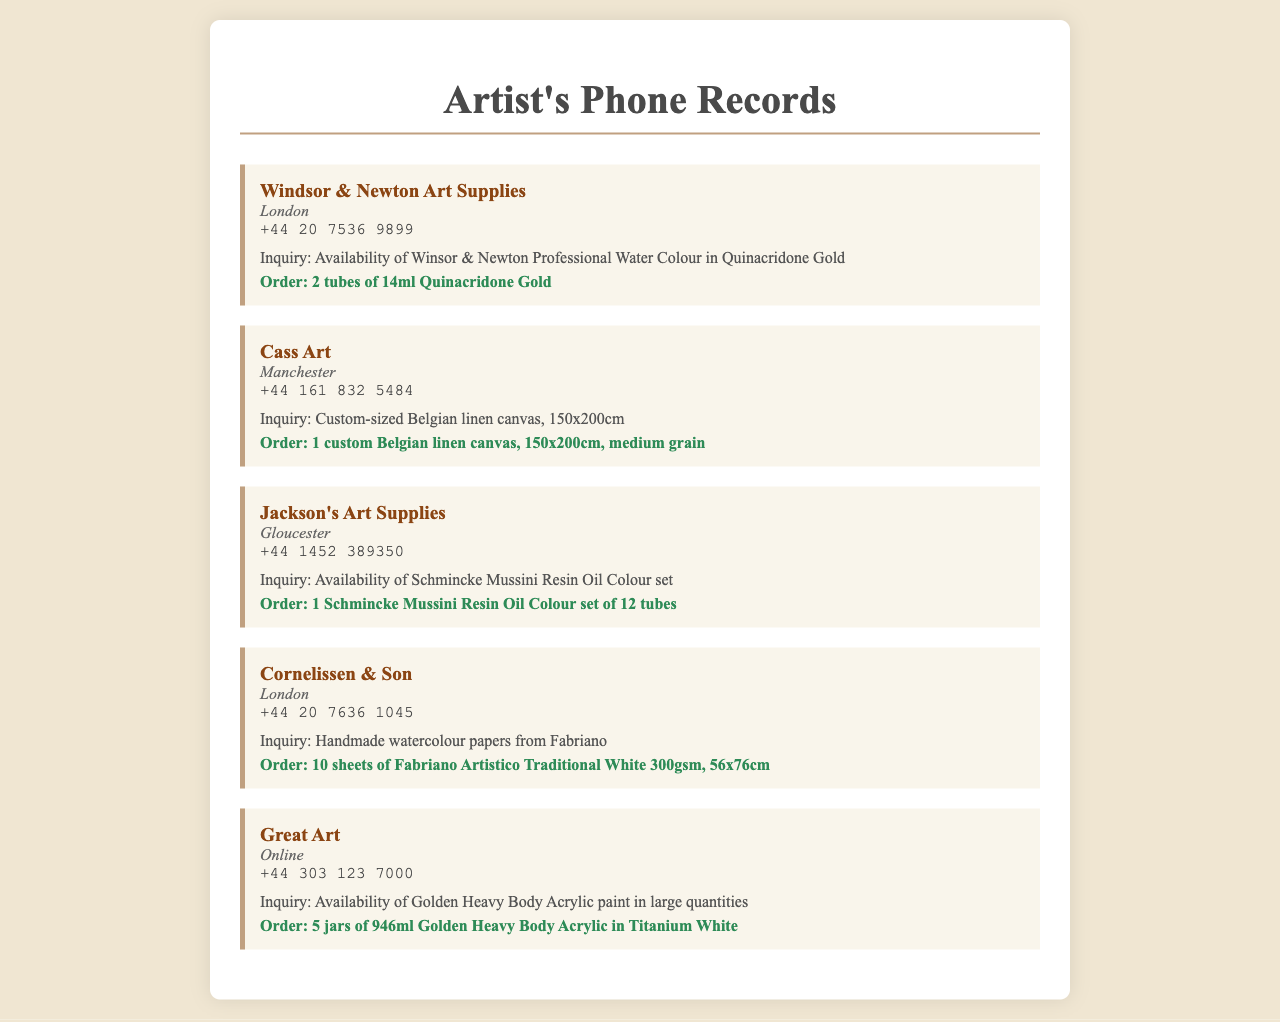what is the name of the first art supply store? The first art supply store listed in the document is Windsor & Newton Art Supplies.
Answer: Windsor & Newton Art Supplies what city is Cass Art located in? Cass Art is located in Manchester as per the document.
Answer: Manchester how many tubes of Quinacridone Gold were ordered? The order for Quinacridone Gold was for 2 tubes as noted in the inquiry.
Answer: 2 tubes what is the size of the custom Belgian linen canvas? The size mentioned for the custom Belgian linen canvas is 150x200cm.
Answer: 150x200cm which brand of oil colour set was inquired about at Jackson's Art Supplies? The inquiry at Jackson's Art Supplies was about the Schmincke Mussini Resin Oil Colour set.
Answer: Schmincke Mussini Resin Oil Colour how many sheets of Fabriano Artistico paper were ordered? The document states that 10 sheets of Fabriano Artistico paper were ordered.
Answer: 10 sheets what type of paint did Great Art inquire about? Great Art inquired about the Golden Heavy Body Acrylic paint.
Answer: Golden Heavy Body Acrylic which store is located online? The store that is indicated as online is Great Art.
Answer: Great Art how many jars of Golden Heavy Body Acrylic in Titanium White were ordered? The order was for 5 jars of Golden Heavy Body Acrylic in Titanium White.
Answer: 5 jars 